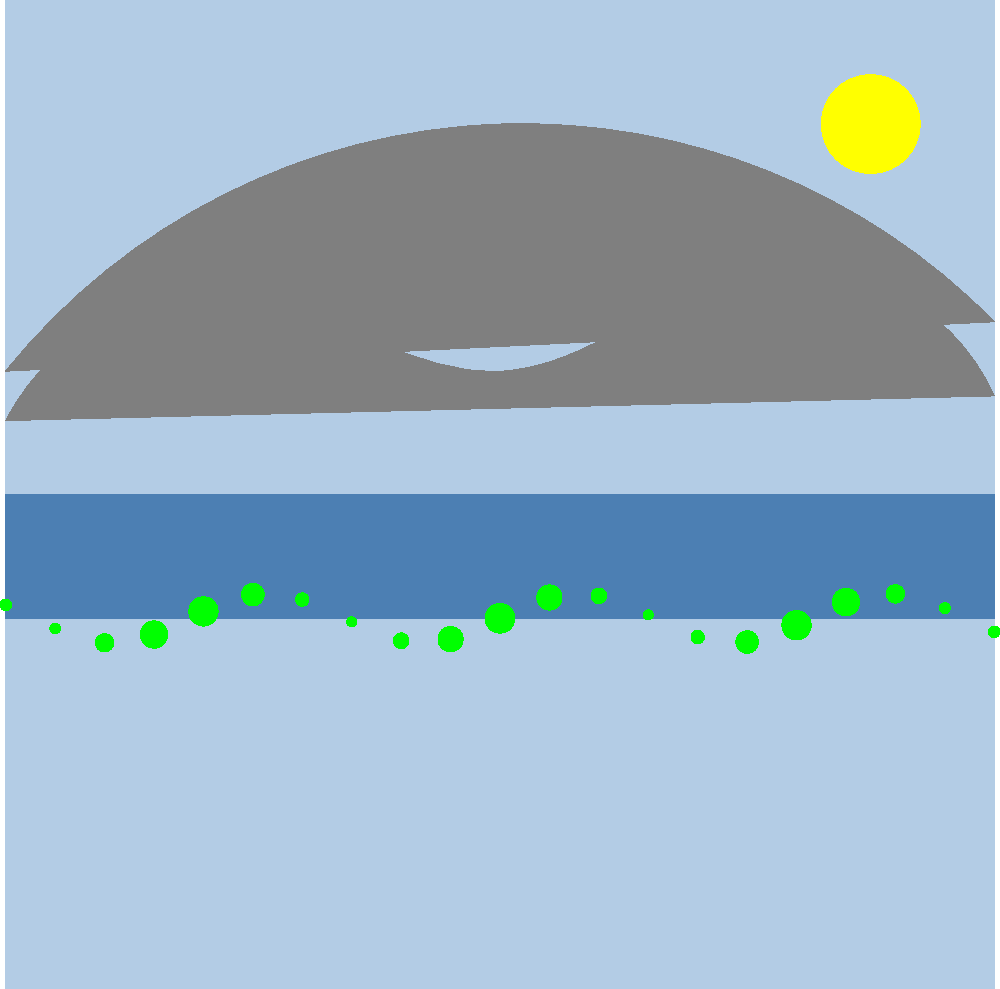As an editor specializing in descriptive writing, how would you advise an author to enhance their setting description based on the landscape photograph shown above? Focus on the interplay of elements and the mood they create. To advise an author on enhancing their setting description based on this landscape photograph, consider the following steps:

1. Identify key elements: 
   - Mountains in the background
   - A lake in the foreground
   - A line of trees along the lakeshore
   - The sun in the upper right corner
   - A clear sky

2. Analyze the composition:
   - The mountains create a sense of scale and grandeur
   - The lake reflects the sky, adding depth to the scene
   - The trees provide a transition between water and land
   - The sun suggests time of day and lighting conditions

3. Consider the mood:
   - The calm water and clear sky imply serenity
   - The vibrant colors (blue sky, green trees) suggest vitality
   - The sun's position might indicate early morning or late afternoon

4. Advise on descriptive techniques:
   a) Use sensory details:
      - Visual: Describe colors, shapes, and light
      - Auditory: Imagine sounds of water, rustling leaves
      - Tactile: Describe temperature, breeze, texture of surroundings
   
   b) Employ figurative language:
      - Similes or metaphors to compare elements (e.g., "mountains like sentinels")
      - Personification to bring the landscape to life
   
   c) Vary sentence structure:
      - Use both short, impactful sentences and longer, flowing ones to mirror the landscape's features

   d) Create movement:
      - Describe subtle changes like shifting sunlight or ripples on the water

   e) Establish perspective:
      - Consider describing the scene from different viewpoints (e.g., from the shore, from a boat)

5. Emphasize the interplay of elements:
   - How the sun's light affects the appearance of the mountains and lake
   - The contrast between the solid mountains and fluid water
   - The reflection of the sky and mountains in the lake

6. Suggest focusing on unique or striking features:
   - The particular shape of the mountain peaks
   - The pattern or density of the trees along the shore
   - Any distinctive colors or lighting effects

By following these steps, the author can create a rich, immersive description that captures both the physical details and the atmosphere of the landscape.
Answer: Advise focusing on sensory details, figurative language, varied sentence structure, movement, perspective, and element interplay to create an immersive, atmospheric description. 